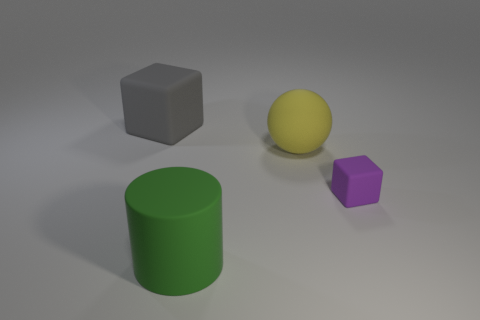Add 4 large green things. How many objects exist? 8 Subtract all purple blocks. How many blocks are left? 1 Subtract 0 yellow blocks. How many objects are left? 4 Subtract all balls. How many objects are left? 3 Subtract all blue balls. Subtract all purple cylinders. How many balls are left? 1 Subtract all tiny matte objects. Subtract all large blocks. How many objects are left? 2 Add 3 gray matte objects. How many gray matte objects are left? 4 Add 2 purple blocks. How many purple blocks exist? 3 